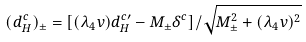<formula> <loc_0><loc_0><loc_500><loc_500>( d ^ { c } _ { H } ) _ { \pm } = [ ( { \lambda _ { 4 } } v ) d ^ { c \prime } _ { H } - M _ { \pm } { \delta ^ { c } } ] / { \sqrt { M ^ { 2 } _ { \pm } + ( { \lambda _ { 4 } } v ) ^ { 2 } } }</formula> 